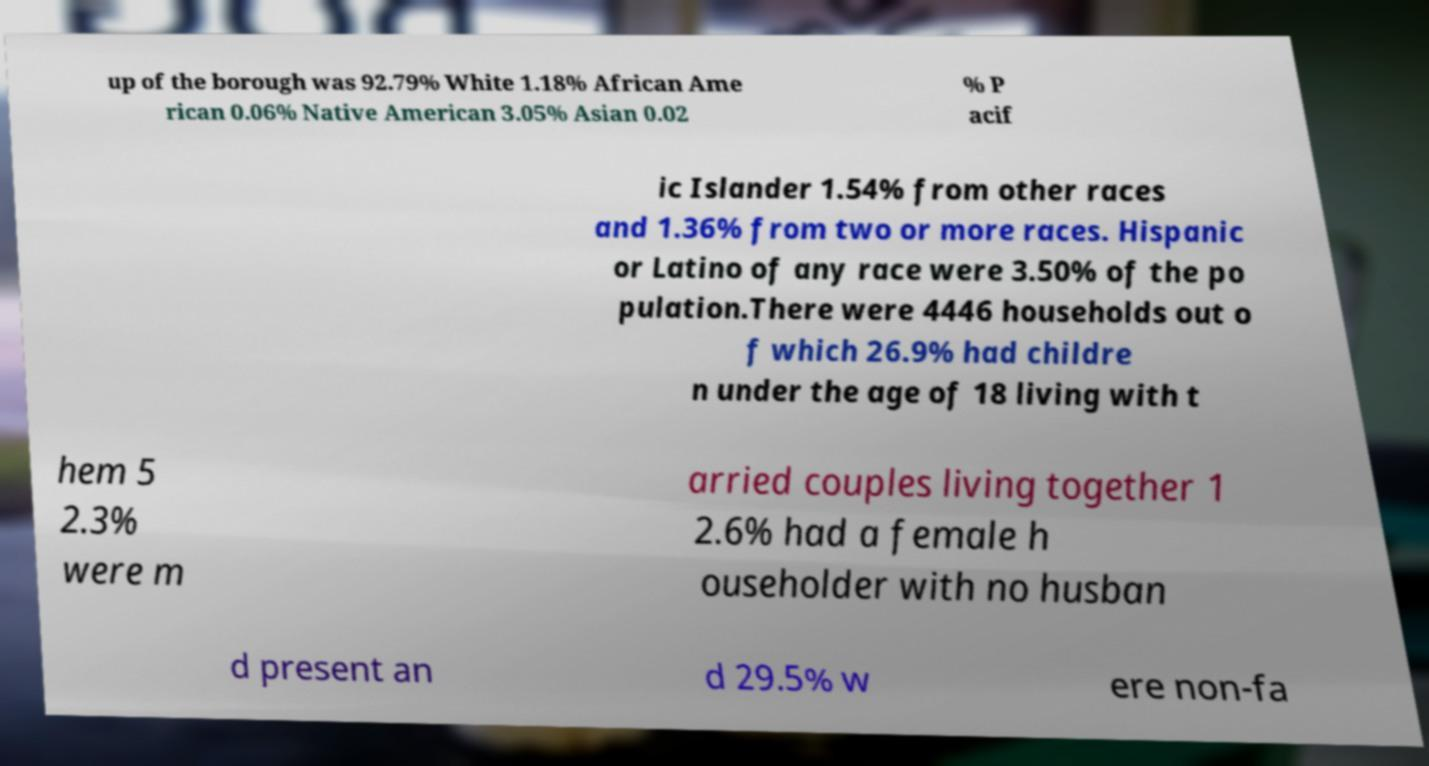For documentation purposes, I need the text within this image transcribed. Could you provide that? up of the borough was 92.79% White 1.18% African Ame rican 0.06% Native American 3.05% Asian 0.02 % P acif ic Islander 1.54% from other races and 1.36% from two or more races. Hispanic or Latino of any race were 3.50% of the po pulation.There were 4446 households out o f which 26.9% had childre n under the age of 18 living with t hem 5 2.3% were m arried couples living together 1 2.6% had a female h ouseholder with no husban d present an d 29.5% w ere non-fa 